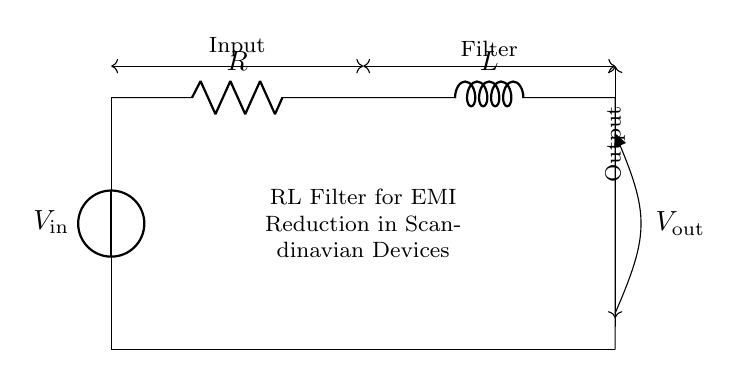What are the components in this circuit? The components in the circuit are a voltage source labeled V in, a resistor labeled R, and an inductor labeled L. Each component is represented by its corresponding symbol in the diagram.
Answer: voltage source, resistor, inductor What is the purpose of the RL filter? The purpose of the RL filter is to reduce electromagnetic interference, which is crucial for the performance of Scandinavian electronic devices that may be susceptible to noise.
Answer: reduce electromagnetic interference What is the position of the voltage output in this circuit? The voltage output is positioned at the bottom of the inductor connected to ground, labeled as V out on the circuit diagram. It shows where the filtered voltage is taken from.
Answer: bottom of the inductor What is the current flow direction in the circuit? The current flows from the positive terminal of the voltage source V in, through the resistor R, then through the inductor L, and finally back to ground. This explains the loop created by the connections of the components.
Answer: clockwise What happens to high-frequency signals in the RL filter? High-frequency signals are attenuated by the inductor L, which opposes rapid changes in current, resulting in a lower output voltage for those frequencies. The combination of resistance and inductance significantly affects how the circuit behaves.
Answer: attenuated How would you describe the circuit's impedance? The impedance of the RL circuit is a combination of resistance and inductance, calculated using the formula: Z = √(R² + (XL)²), where XL is the inductive reactance. This means the total impedance varies with frequency, influencing the filter's performance.
Answer: R² + (XL)² 